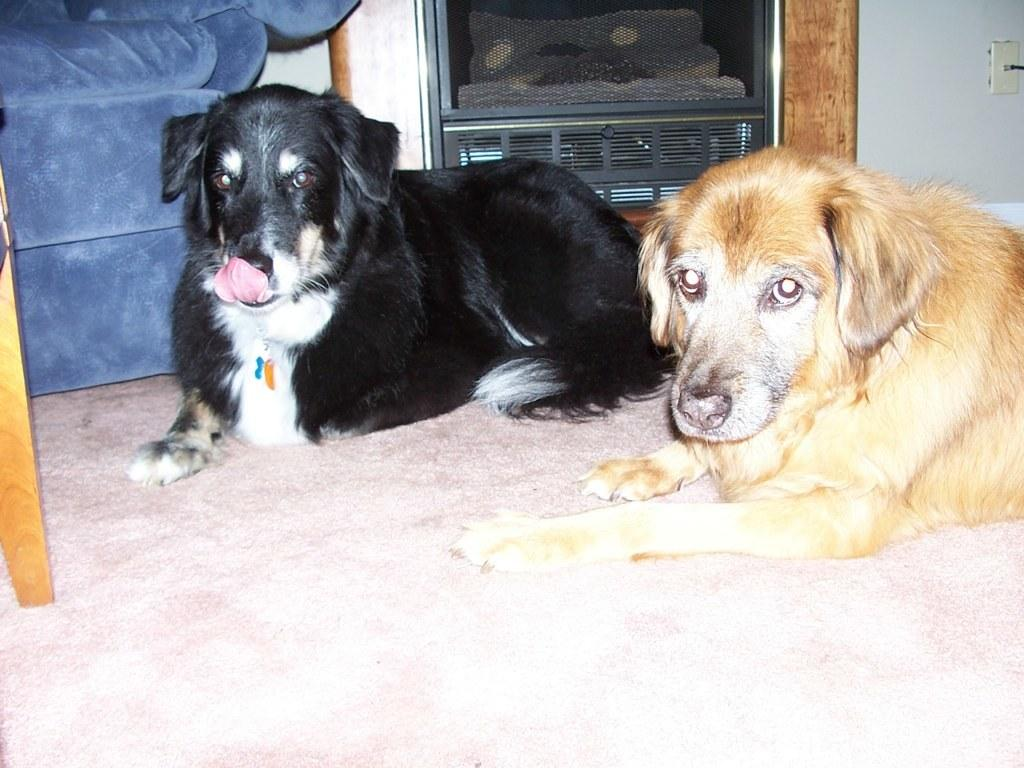How many dogs are present in the image? There are two dogs lying on the floor in the image. What can be seen in the background of the image? There is a couch, a cupboard, a wall, and a board in the background of the image. What type of cough does the carpenter have in the image? There is no carpenter or cough present in the image. Does the dog on the left show any signs of regret in the image? There is no indication of regret in the image; the dogs are simply lying on the floor. 